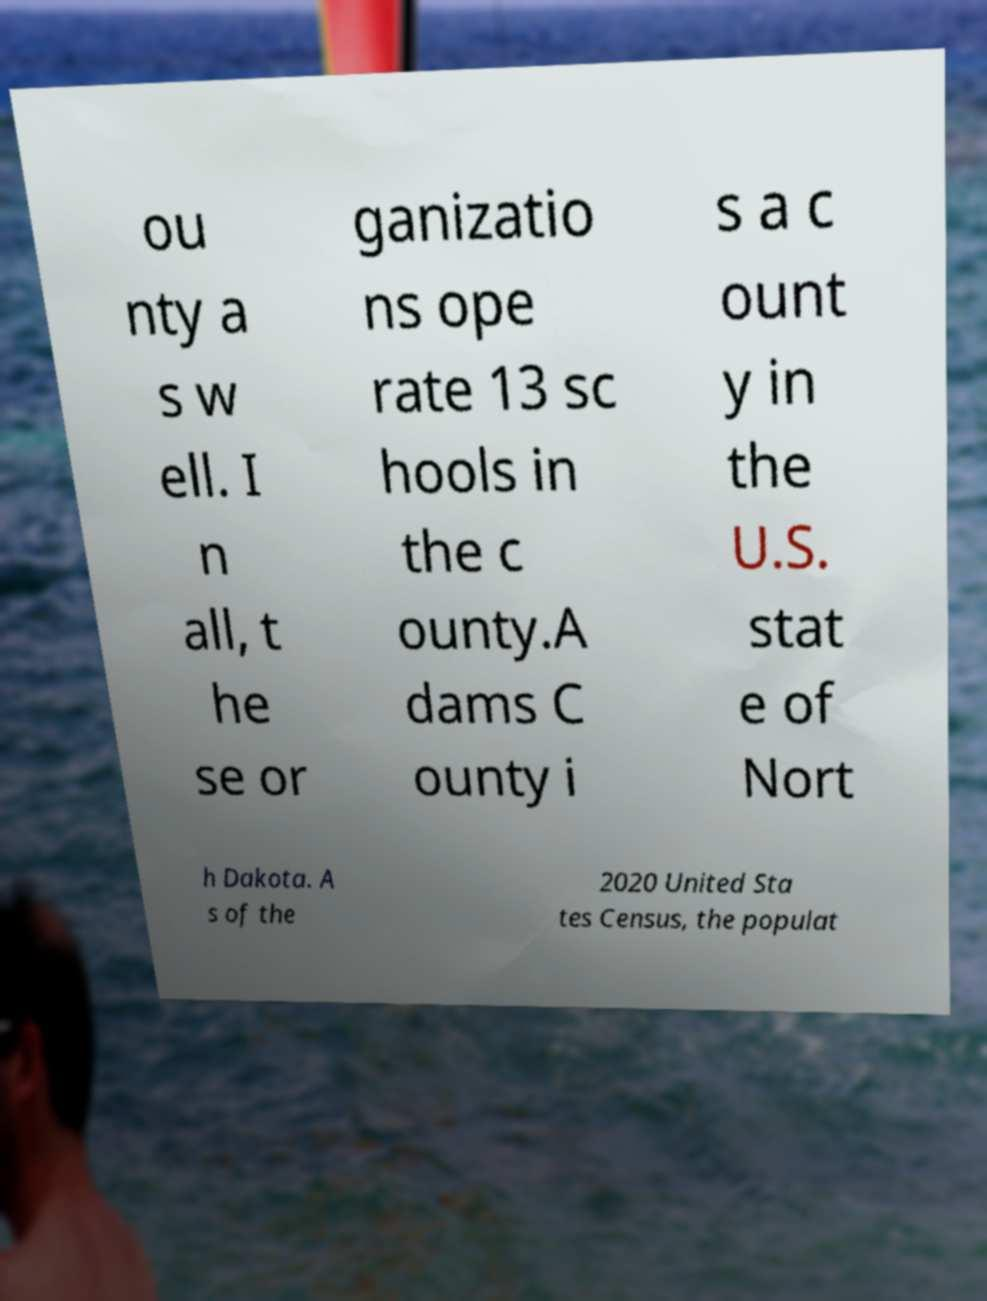Could you assist in decoding the text presented in this image and type it out clearly? ou nty a s w ell. I n all, t he se or ganizatio ns ope rate 13 sc hools in the c ounty.A dams C ounty i s a c ount y in the U.S. stat e of Nort h Dakota. A s of the 2020 United Sta tes Census, the populat 